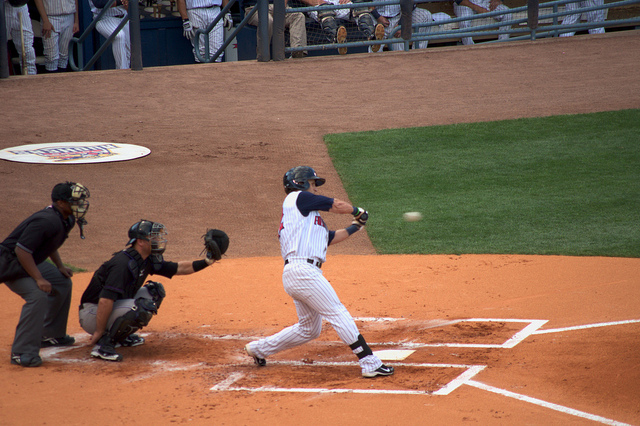What is happening in the image? A baseball batter is attempting to hit a pitch during a game, while a catcher and an umpire are in position behind the home plate. 